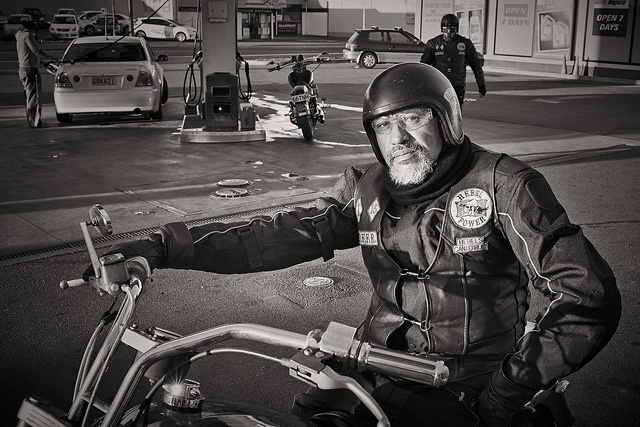Describe the objects in this image and their specific colors. I can see people in black, gray, darkgray, and lightgray tones, motorcycle in black, gray, darkgray, and lightgray tones, car in black, gray, and darkgray tones, people in black, gray, and darkgray tones, and car in black, gray, darkgray, and lightgray tones in this image. 